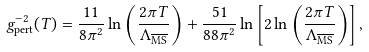<formula> <loc_0><loc_0><loc_500><loc_500>g ^ { - 2 } _ { \text {pert} } ( T ) = \frac { 1 1 } { 8 \pi ^ { 2 } } \ln \left ( \frac { 2 \pi T } { \Lambda _ { \overline { \text {MS} } } } \right ) + \frac { 5 1 } { 8 8 \pi ^ { 2 } } \ln \left [ 2 \ln \left ( \frac { 2 \pi T } { \Lambda _ { \overline { \text {MS} } } } \right ) \right ] ,</formula> 